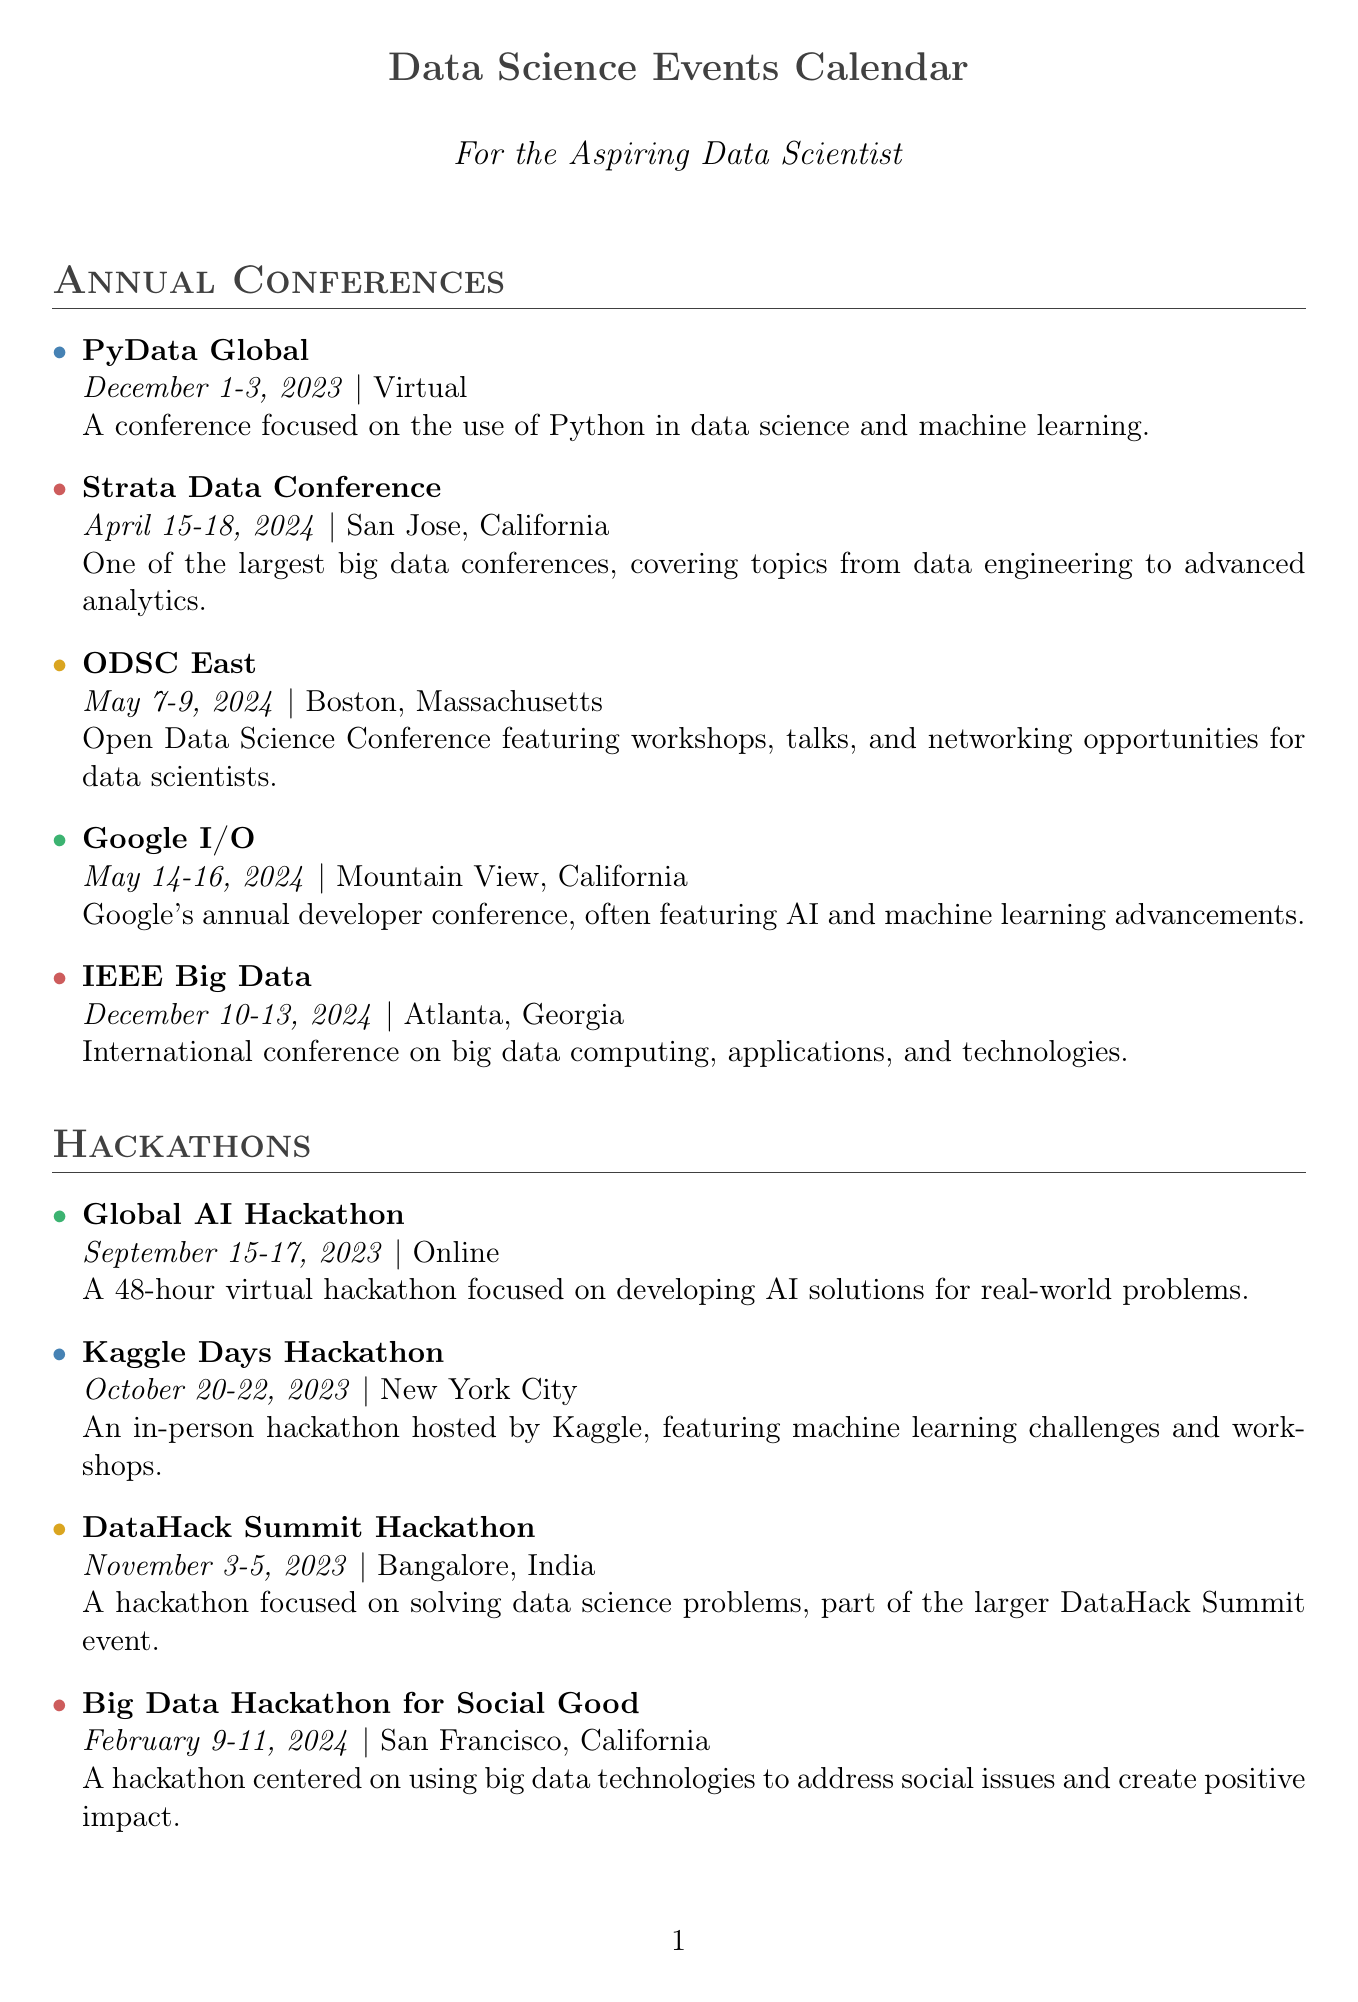what is the date for PyData Global? The date for PyData Global is mentioned as December 1-3, 2023.
Answer: December 1-3, 2023 where will the Strata Data Conference take place? The location for the Strata Data Conference is San Jose, California.
Answer: San Jose, California which category does Google I/O belong to? The category listed for Google I/O is AI.
Answer: AI how many hackathons are there in September 2023? There is one hackathon listed in September 2023, which is the Global AI Hackathon.
Answer: one what type of workshop is scheduled for January 18-19, 2024? The workshop scheduled for that date is about MLOps and ML Engineering Best Practices.
Answer: MLOps & ML Engineering Best Practices which hackathon focuses on big data for social good? The hackathon that focuses on big data for social good is called Big Data Hackathon for Social Good.
Answer: Big Data Hackathon for Social Good how many days does the Deep Learning Bootcamp last? The Deep Learning Bootcamp lasts for five days.
Answer: five days which city is the DataHack Summit Hackathon held in? The DataHack Summit Hackathon is held in Bangalore, India.
Answer: Bangalore, India 